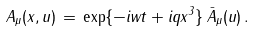Convert formula to latex. <formula><loc_0><loc_0><loc_500><loc_500>A _ { \mu } ( x , u ) \, = \, \exp \{ - i w t + i q x ^ { 3 } \} \, { \bar { A } } _ { \mu } ( u ) \, .</formula> 